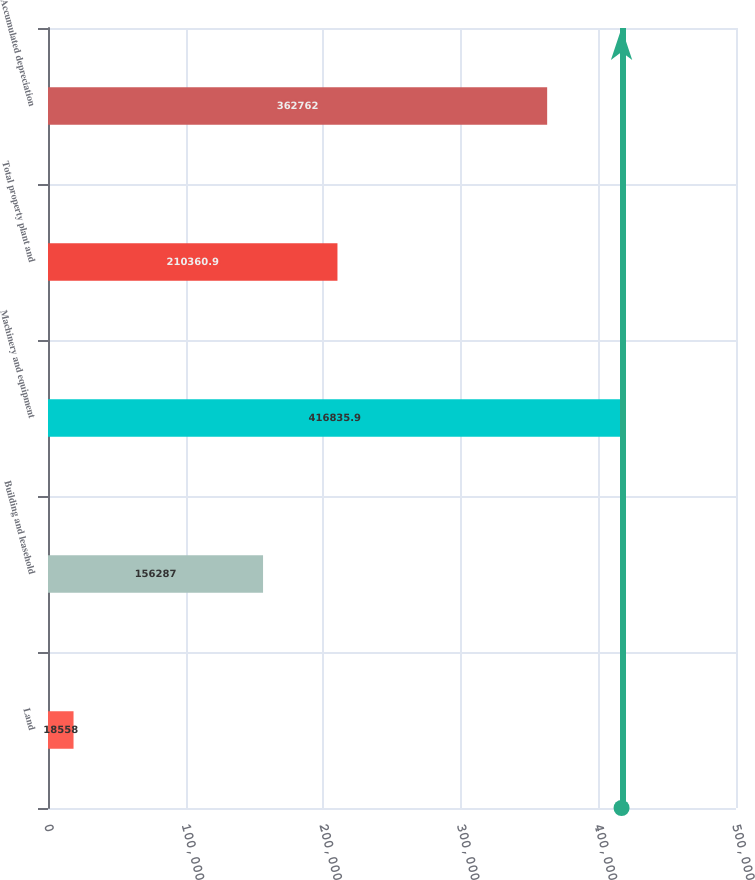<chart> <loc_0><loc_0><loc_500><loc_500><bar_chart><fcel>Land<fcel>Building and leasehold<fcel>Machinery and equipment<fcel>Total property plant and<fcel>Accumulated depreciation<nl><fcel>18558<fcel>156287<fcel>416836<fcel>210361<fcel>362762<nl></chart> 